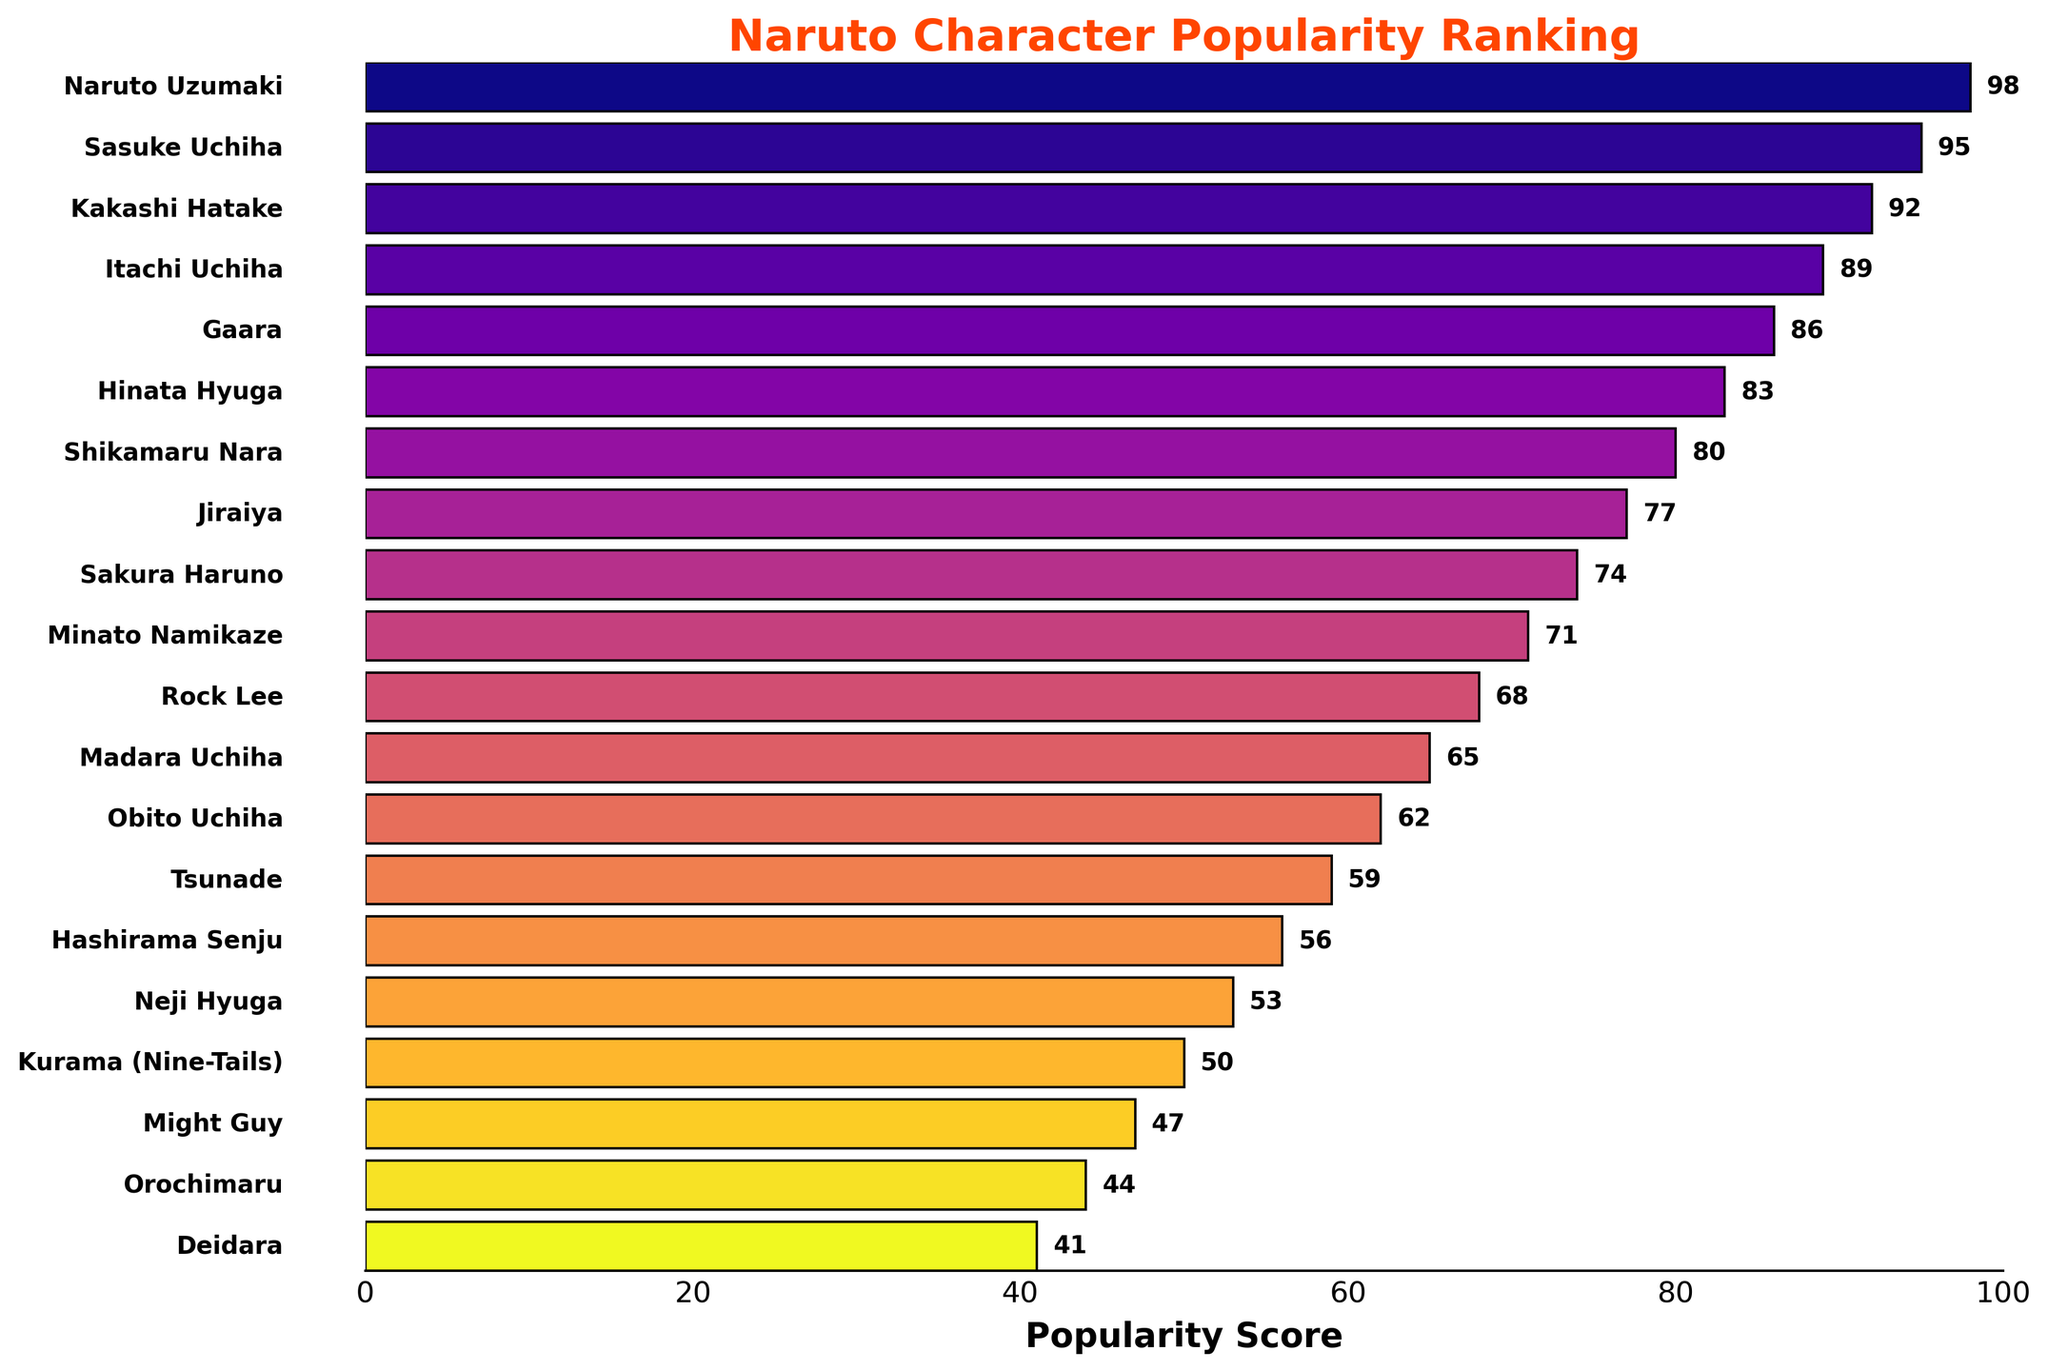What is the most popular character? To determine the most popular character, look for the bar with the highest length/score on the x-axis. The longest bar represents Naruto Uzumaki.
Answer: Naruto Uzumaki Who is more popular, Sasuke Uchiha or Kakashi Hatake? Compare the lengths of the bars for Sasuke Uchiha and Kakashi Hatake. Sasuke's bar is slightly longer than Kakashi's, indicating a higher score.
Answer: Sasuke Uchiha What is the total popularity score for the Uchiha family members (Sasuke, Itachi, Madara, Obito)? Add up the popularity scores: Sasuke (95) + Itachi (89) + Madara (65) + Obito (62). The total is 311.
Answer: 311 Which character is least popular according to the poll? Identify the shortest bar on the chart. The shortest bar represents Deidara.
Answer: Deidara What is the difference in popularity scores between Naruto Uzumaki and his father, Minato Namikaze? Subtract Minato's score (71) from Naruto's score (98). The difference is 27.
Answer: 27 Which characters have a popularity score greater than 90? Look at the bars, and identify those with a score greater than 90. These characters are Naruto Uzumaki, Sasuke Uchiha, and Kakashi Hatake.
Answer: Naruto Uzumaki, Sasuke Uchiha, Kakashi Hatake What is the average popularity score of the top five characters? Add the scores of the top five characters: Naruto (98), Sasuke (95), Kakashi (92), Itachi (89), and Gaara (86), then divide by 5. The average is (98 + 95 + 92 + 89 + 86) / 5 = 92.
Answer: 92 How many characters have a popularity score less than 50? Count the bars on the chart with scores less than 50. The characters are Might Guy, Orochimaru, and Deidara. There are 3 characters.
Answer: 3 Which has a higher popularity score: Sakura Haruno or Hinata Hyuga? Compare the lengths of the bars for Sakura Haruno and Hinata Hyuga. Hinata's bar is longer than Sakura's, indicating a higher score.
Answer: Hinata Hyuga What is the popularity score for the character ranked tenth? Identify the bar that represents the tenth character, which is Minato Namikaze. His score is 71.
Answer: 71 